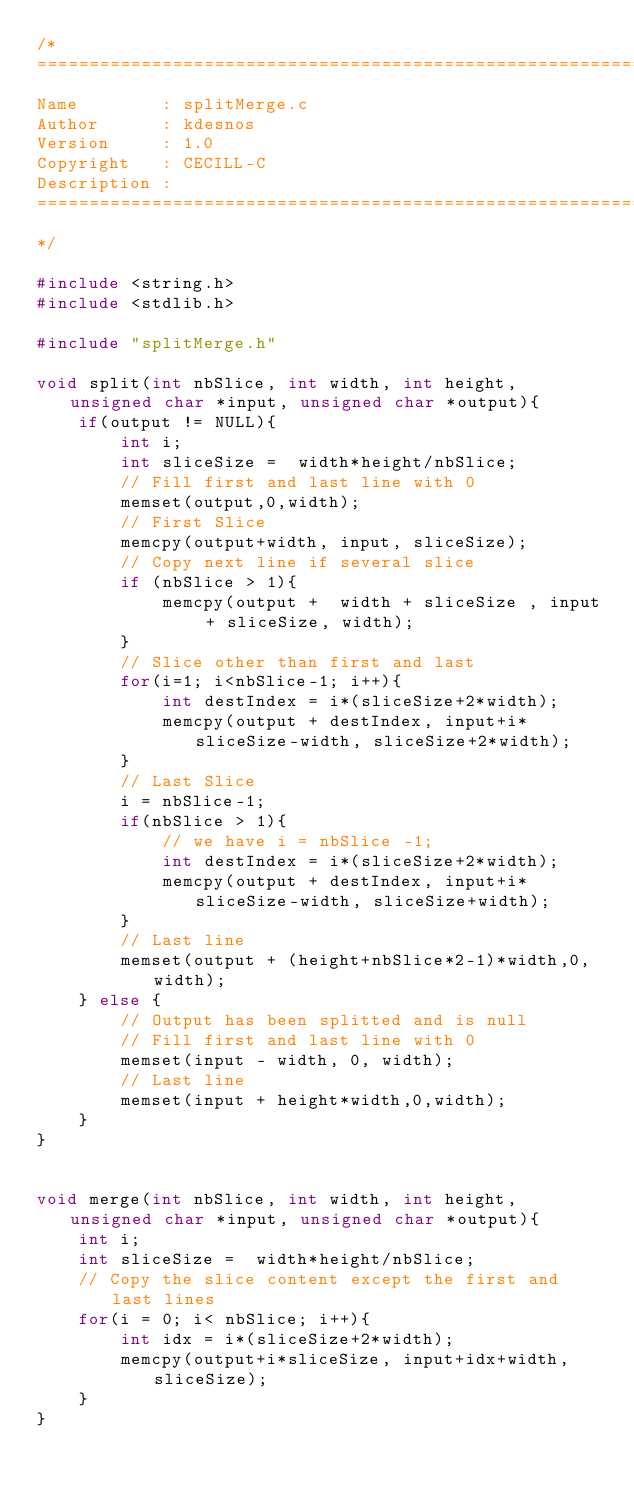<code> <loc_0><loc_0><loc_500><loc_500><_C_>/*
============================================================================
Name        : splitMerge.c
Author      : kdesnos
Version     : 1.0
Copyright   : CECILL-C
Description :
============================================================================
*/

#include <string.h>
#include <stdlib.h>

#include "splitMerge.h"

void split(int nbSlice, int width, int height, unsigned char *input, unsigned char *output){
	if(output != NULL){
		int i;
		int sliceSize =  width*height/nbSlice;
		// Fill first and last line with 0
		memset(output,0,width);
		// First Slice
		memcpy(output+width, input, sliceSize);
		// Copy next line if several slice
		if (nbSlice > 1){
			memcpy(output +  width + sliceSize , input + sliceSize, width);
		}
		// Slice other than first and last
		for(i=1; i<nbSlice-1; i++){
			int destIndex = i*(sliceSize+2*width);
			memcpy(output + destIndex, input+i*sliceSize-width, sliceSize+2*width);
		}
		// Last Slice
		i = nbSlice-1;
		if(nbSlice > 1){
			// we have i = nbSlice -1;
			int destIndex = i*(sliceSize+2*width);
			memcpy(output + destIndex, input+i*sliceSize-width, sliceSize+width);
		}
		// Last line
		memset(output + (height+nbSlice*2-1)*width,0,width);
	} else {
		// Output has been splitted and is null
		// Fill first and last line with 0
		memset(input - width, 0, width);
		// Last line
		memset(input + height*width,0,width);
	}
}


void merge(int nbSlice, int width, int height, unsigned char *input, unsigned char *output){
	int i;
	int sliceSize =  width*height/nbSlice;
	// Copy the slice content except the first and last lines
	for(i = 0; i< nbSlice; i++){
		int idx = i*(sliceSize+2*width);
		memcpy(output+i*sliceSize, input+idx+width, sliceSize);
	}
}

</code> 